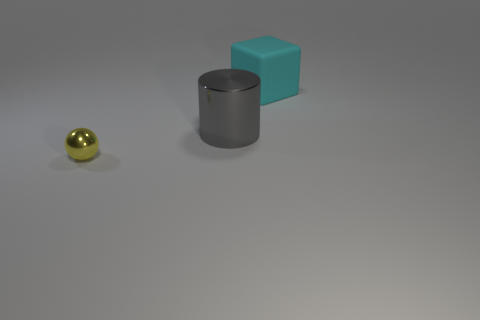What number of other yellow metal objects are the same shape as the yellow thing?
Offer a terse response. 0. What is the size of the sphere that is made of the same material as the cylinder?
Give a very brief answer. Small. There is a object that is to the right of the yellow object and in front of the large cyan matte object; what is its color?
Offer a terse response. Gray. What number of gray shiny cylinders are the same size as the matte thing?
Offer a very short reply. 1. What is the size of the object that is on the right side of the tiny metallic sphere and in front of the large matte block?
Provide a succinct answer. Large. What number of shiny objects are on the right side of the object that is in front of the metallic thing that is on the right side of the yellow object?
Give a very brief answer. 1. Is there a large rubber sphere that has the same color as the metallic cylinder?
Your answer should be compact. No. There is a matte cube that is the same size as the cylinder; what is its color?
Your answer should be very brief. Cyan. The metallic thing that is to the right of the thing on the left side of the large object in front of the big cyan rubber block is what shape?
Provide a succinct answer. Cylinder. How many large cubes are on the right side of the metal object that is behind the yellow thing?
Offer a terse response. 1. 